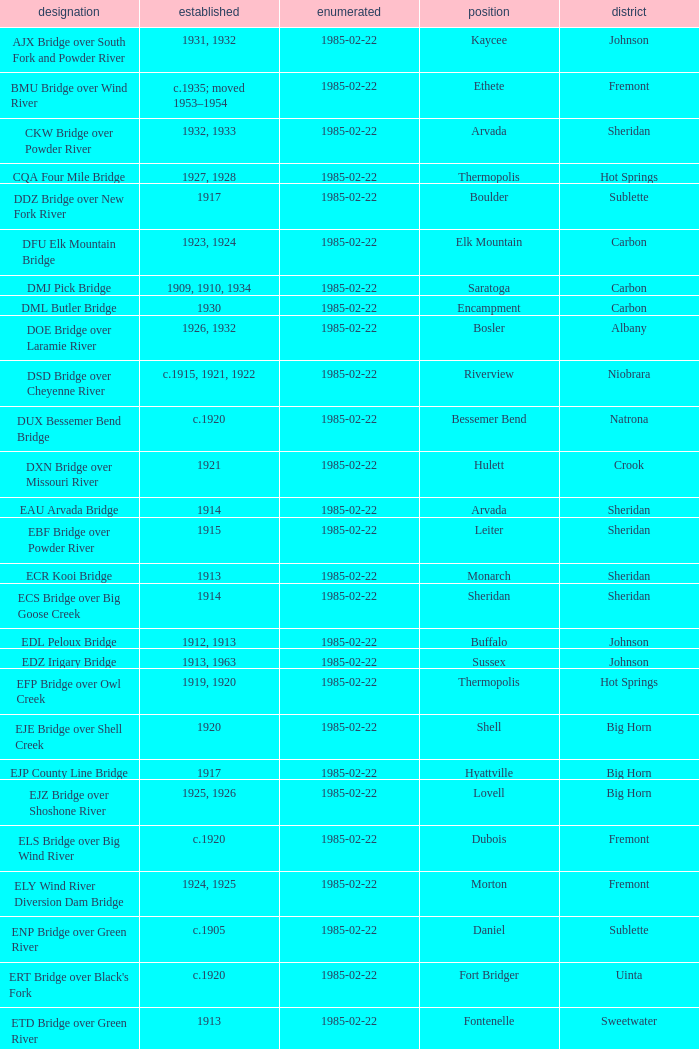What county is home to the bridge in boulder? Sublette. 